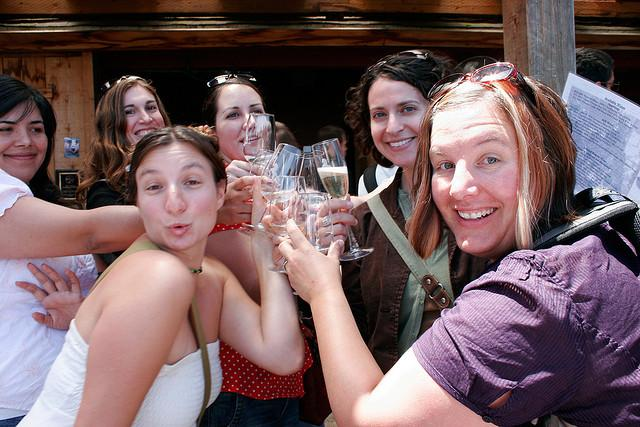What are the woman raising?

Choices:
A) cows
B) glasses
C) chickens
D) graduation hats glasses 